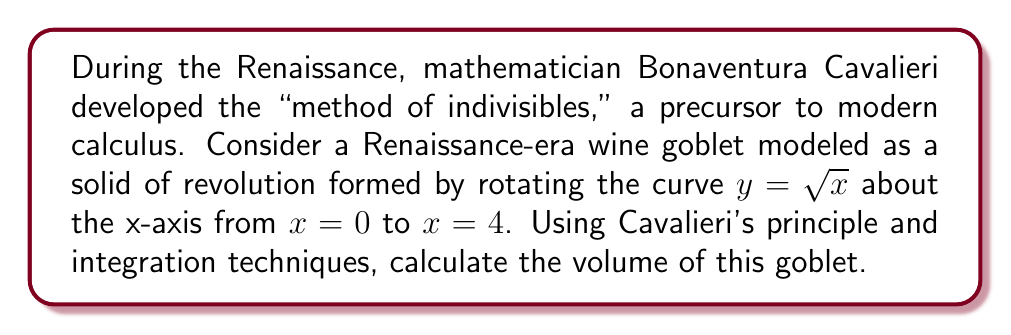Can you solve this math problem? 1) Cavalieri's principle states that the volume of a solid can be found by integrating the areas of its cross-sections. In this case, we'll use the method of washer disks.

2) The cross-sectional area at any point $x$ is a circular disk with a radius of $y = \sqrt{x}$.

3) The area of each disk is $A(x) = \pi r^2 = \pi (\sqrt{x})^2 = \pi x$.

4) To find the volume, we integrate these areas from $x = 0$ to $x = 4$:

   $$V = \int_0^4 \pi x \, dx$$

5) Evaluate the integral:
   $$\begin{align}
   V &= \pi \int_0^4 x \, dx \\
   &= \pi \left[ \frac{1}{2}x^2 \right]_0^4 \\
   &= \pi \left( \frac{1}{2}(4^2) - \frac{1}{2}(0^2) \right) \\
   &= \pi \left( 8 - 0 \right) \\
   &= 8\pi
   \end{align}$$

6) Therefore, the volume of the goblet is $8\pi$ cubic units.
Answer: $8\pi$ cubic units 